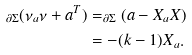<formula> <loc_0><loc_0><loc_500><loc_500>_ { \partial \Sigma } ( \nu _ { a } \nu + a ^ { T } ) & = _ { \partial \Sigma } ( a - X _ { a } X ) \\ & = - ( k - 1 ) X _ { a } .</formula> 